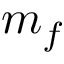<formula> <loc_0><loc_0><loc_500><loc_500>m _ { f }</formula> 